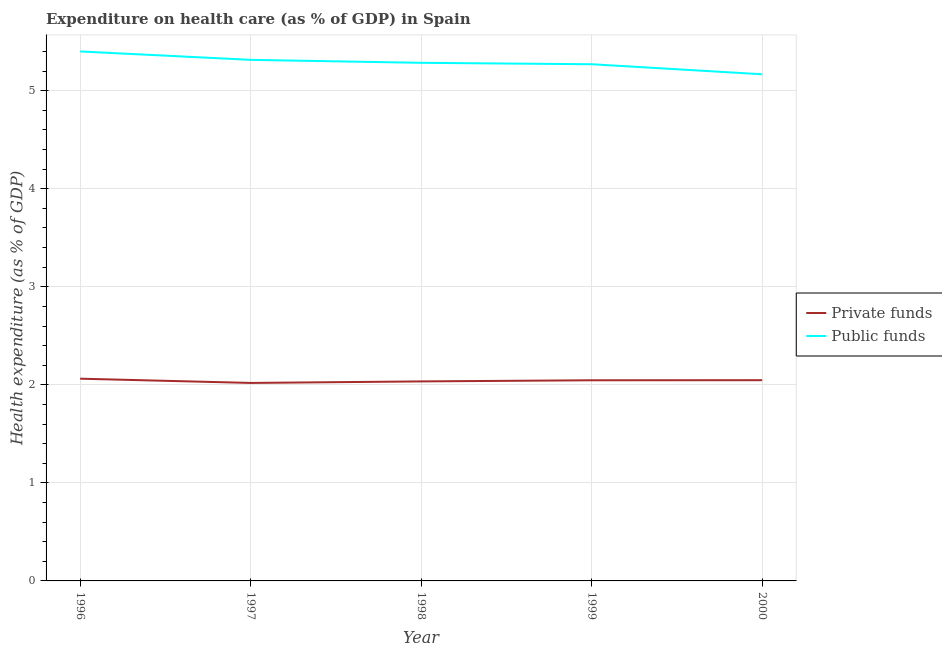Does the line corresponding to amount of public funds spent in healthcare intersect with the line corresponding to amount of private funds spent in healthcare?
Make the answer very short. No. Is the number of lines equal to the number of legend labels?
Provide a short and direct response. Yes. What is the amount of private funds spent in healthcare in 1996?
Provide a succinct answer. 2.06. Across all years, what is the maximum amount of private funds spent in healthcare?
Offer a terse response. 2.06. Across all years, what is the minimum amount of public funds spent in healthcare?
Keep it short and to the point. 5.17. What is the total amount of private funds spent in healthcare in the graph?
Offer a terse response. 10.21. What is the difference between the amount of public funds spent in healthcare in 1996 and that in 1998?
Make the answer very short. 0.12. What is the difference between the amount of private funds spent in healthcare in 1997 and the amount of public funds spent in healthcare in 2000?
Your answer should be compact. -3.15. What is the average amount of private funds spent in healthcare per year?
Ensure brevity in your answer.  2.04. In the year 2000, what is the difference between the amount of public funds spent in healthcare and amount of private funds spent in healthcare?
Offer a very short reply. 3.12. In how many years, is the amount of private funds spent in healthcare greater than 1.8 %?
Your answer should be compact. 5. What is the ratio of the amount of private funds spent in healthcare in 1997 to that in 1998?
Offer a very short reply. 0.99. Is the difference between the amount of private funds spent in healthcare in 1998 and 2000 greater than the difference between the amount of public funds spent in healthcare in 1998 and 2000?
Offer a terse response. No. What is the difference between the highest and the second highest amount of public funds spent in healthcare?
Offer a very short reply. 0.09. What is the difference between the highest and the lowest amount of public funds spent in healthcare?
Your response must be concise. 0.23. Does the amount of public funds spent in healthcare monotonically increase over the years?
Give a very brief answer. No. How many years are there in the graph?
Your response must be concise. 5. What is the difference between two consecutive major ticks on the Y-axis?
Keep it short and to the point. 1. Where does the legend appear in the graph?
Provide a succinct answer. Center right. How many legend labels are there?
Ensure brevity in your answer.  2. What is the title of the graph?
Give a very brief answer. Expenditure on health care (as % of GDP) in Spain. Does "Broad money growth" appear as one of the legend labels in the graph?
Provide a succinct answer. No. What is the label or title of the Y-axis?
Make the answer very short. Health expenditure (as % of GDP). What is the Health expenditure (as % of GDP) of Private funds in 1996?
Provide a succinct answer. 2.06. What is the Health expenditure (as % of GDP) in Public funds in 1996?
Offer a terse response. 5.4. What is the Health expenditure (as % of GDP) of Private funds in 1997?
Provide a succinct answer. 2.02. What is the Health expenditure (as % of GDP) in Public funds in 1997?
Your response must be concise. 5.31. What is the Health expenditure (as % of GDP) in Private funds in 1998?
Your answer should be compact. 2.03. What is the Health expenditure (as % of GDP) of Public funds in 1998?
Provide a short and direct response. 5.28. What is the Health expenditure (as % of GDP) in Private funds in 1999?
Make the answer very short. 2.05. What is the Health expenditure (as % of GDP) of Public funds in 1999?
Provide a short and direct response. 5.27. What is the Health expenditure (as % of GDP) of Private funds in 2000?
Provide a short and direct response. 2.05. What is the Health expenditure (as % of GDP) of Public funds in 2000?
Your response must be concise. 5.17. Across all years, what is the maximum Health expenditure (as % of GDP) in Private funds?
Ensure brevity in your answer.  2.06. Across all years, what is the maximum Health expenditure (as % of GDP) of Public funds?
Your answer should be compact. 5.4. Across all years, what is the minimum Health expenditure (as % of GDP) in Private funds?
Your answer should be very brief. 2.02. Across all years, what is the minimum Health expenditure (as % of GDP) in Public funds?
Keep it short and to the point. 5.17. What is the total Health expenditure (as % of GDP) in Private funds in the graph?
Make the answer very short. 10.21. What is the total Health expenditure (as % of GDP) of Public funds in the graph?
Your answer should be very brief. 26.44. What is the difference between the Health expenditure (as % of GDP) in Private funds in 1996 and that in 1997?
Make the answer very short. 0.04. What is the difference between the Health expenditure (as % of GDP) of Public funds in 1996 and that in 1997?
Ensure brevity in your answer.  0.09. What is the difference between the Health expenditure (as % of GDP) in Private funds in 1996 and that in 1998?
Keep it short and to the point. 0.03. What is the difference between the Health expenditure (as % of GDP) of Public funds in 1996 and that in 1998?
Your answer should be compact. 0.12. What is the difference between the Health expenditure (as % of GDP) in Private funds in 1996 and that in 1999?
Offer a terse response. 0.02. What is the difference between the Health expenditure (as % of GDP) of Public funds in 1996 and that in 1999?
Your response must be concise. 0.13. What is the difference between the Health expenditure (as % of GDP) of Private funds in 1996 and that in 2000?
Keep it short and to the point. 0.02. What is the difference between the Health expenditure (as % of GDP) of Public funds in 1996 and that in 2000?
Provide a succinct answer. 0.23. What is the difference between the Health expenditure (as % of GDP) in Private funds in 1997 and that in 1998?
Offer a terse response. -0.02. What is the difference between the Health expenditure (as % of GDP) of Public funds in 1997 and that in 1998?
Offer a very short reply. 0.03. What is the difference between the Health expenditure (as % of GDP) of Private funds in 1997 and that in 1999?
Ensure brevity in your answer.  -0.03. What is the difference between the Health expenditure (as % of GDP) in Public funds in 1997 and that in 1999?
Provide a succinct answer. 0.04. What is the difference between the Health expenditure (as % of GDP) of Private funds in 1997 and that in 2000?
Your response must be concise. -0.03. What is the difference between the Health expenditure (as % of GDP) of Public funds in 1997 and that in 2000?
Provide a short and direct response. 0.15. What is the difference between the Health expenditure (as % of GDP) in Private funds in 1998 and that in 1999?
Your response must be concise. -0.01. What is the difference between the Health expenditure (as % of GDP) of Public funds in 1998 and that in 1999?
Give a very brief answer. 0.01. What is the difference between the Health expenditure (as % of GDP) of Private funds in 1998 and that in 2000?
Your response must be concise. -0.01. What is the difference between the Health expenditure (as % of GDP) of Public funds in 1998 and that in 2000?
Offer a terse response. 0.12. What is the difference between the Health expenditure (as % of GDP) of Private funds in 1999 and that in 2000?
Provide a succinct answer. -0. What is the difference between the Health expenditure (as % of GDP) of Public funds in 1999 and that in 2000?
Provide a succinct answer. 0.1. What is the difference between the Health expenditure (as % of GDP) of Private funds in 1996 and the Health expenditure (as % of GDP) of Public funds in 1997?
Your response must be concise. -3.25. What is the difference between the Health expenditure (as % of GDP) of Private funds in 1996 and the Health expenditure (as % of GDP) of Public funds in 1998?
Your answer should be very brief. -3.22. What is the difference between the Health expenditure (as % of GDP) of Private funds in 1996 and the Health expenditure (as % of GDP) of Public funds in 1999?
Your response must be concise. -3.21. What is the difference between the Health expenditure (as % of GDP) in Private funds in 1996 and the Health expenditure (as % of GDP) in Public funds in 2000?
Make the answer very short. -3.1. What is the difference between the Health expenditure (as % of GDP) in Private funds in 1997 and the Health expenditure (as % of GDP) in Public funds in 1998?
Offer a terse response. -3.27. What is the difference between the Health expenditure (as % of GDP) of Private funds in 1997 and the Health expenditure (as % of GDP) of Public funds in 1999?
Offer a very short reply. -3.25. What is the difference between the Health expenditure (as % of GDP) in Private funds in 1997 and the Health expenditure (as % of GDP) in Public funds in 2000?
Ensure brevity in your answer.  -3.15. What is the difference between the Health expenditure (as % of GDP) of Private funds in 1998 and the Health expenditure (as % of GDP) of Public funds in 1999?
Provide a short and direct response. -3.23. What is the difference between the Health expenditure (as % of GDP) in Private funds in 1998 and the Health expenditure (as % of GDP) in Public funds in 2000?
Your answer should be very brief. -3.13. What is the difference between the Health expenditure (as % of GDP) in Private funds in 1999 and the Health expenditure (as % of GDP) in Public funds in 2000?
Provide a succinct answer. -3.12. What is the average Health expenditure (as % of GDP) in Private funds per year?
Offer a very short reply. 2.04. What is the average Health expenditure (as % of GDP) in Public funds per year?
Your response must be concise. 5.29. In the year 1996, what is the difference between the Health expenditure (as % of GDP) in Private funds and Health expenditure (as % of GDP) in Public funds?
Your answer should be compact. -3.34. In the year 1997, what is the difference between the Health expenditure (as % of GDP) in Private funds and Health expenditure (as % of GDP) in Public funds?
Keep it short and to the point. -3.3. In the year 1998, what is the difference between the Health expenditure (as % of GDP) of Private funds and Health expenditure (as % of GDP) of Public funds?
Make the answer very short. -3.25. In the year 1999, what is the difference between the Health expenditure (as % of GDP) of Private funds and Health expenditure (as % of GDP) of Public funds?
Provide a succinct answer. -3.22. In the year 2000, what is the difference between the Health expenditure (as % of GDP) of Private funds and Health expenditure (as % of GDP) of Public funds?
Give a very brief answer. -3.12. What is the ratio of the Health expenditure (as % of GDP) in Private funds in 1996 to that in 1997?
Your response must be concise. 1.02. What is the ratio of the Health expenditure (as % of GDP) in Public funds in 1996 to that in 1997?
Offer a very short reply. 1.02. What is the ratio of the Health expenditure (as % of GDP) in Private funds in 1996 to that in 1998?
Make the answer very short. 1.01. What is the ratio of the Health expenditure (as % of GDP) in Public funds in 1996 to that in 1998?
Provide a short and direct response. 1.02. What is the ratio of the Health expenditure (as % of GDP) of Private funds in 1996 to that in 1999?
Your answer should be very brief. 1.01. What is the ratio of the Health expenditure (as % of GDP) of Public funds in 1996 to that in 1999?
Give a very brief answer. 1.02. What is the ratio of the Health expenditure (as % of GDP) of Private funds in 1996 to that in 2000?
Provide a succinct answer. 1.01. What is the ratio of the Health expenditure (as % of GDP) of Public funds in 1996 to that in 2000?
Keep it short and to the point. 1.05. What is the ratio of the Health expenditure (as % of GDP) of Private funds in 1997 to that in 1999?
Give a very brief answer. 0.99. What is the ratio of the Health expenditure (as % of GDP) in Public funds in 1997 to that in 1999?
Make the answer very short. 1.01. What is the ratio of the Health expenditure (as % of GDP) of Private funds in 1997 to that in 2000?
Make the answer very short. 0.99. What is the ratio of the Health expenditure (as % of GDP) in Public funds in 1997 to that in 2000?
Ensure brevity in your answer.  1.03. What is the ratio of the Health expenditure (as % of GDP) of Private funds in 1998 to that in 1999?
Your answer should be very brief. 0.99. What is the ratio of the Health expenditure (as % of GDP) of Public funds in 1998 to that in 2000?
Your answer should be very brief. 1.02. What is the ratio of the Health expenditure (as % of GDP) of Public funds in 1999 to that in 2000?
Keep it short and to the point. 1.02. What is the difference between the highest and the second highest Health expenditure (as % of GDP) in Private funds?
Offer a very short reply. 0.02. What is the difference between the highest and the second highest Health expenditure (as % of GDP) of Public funds?
Provide a succinct answer. 0.09. What is the difference between the highest and the lowest Health expenditure (as % of GDP) in Private funds?
Offer a terse response. 0.04. What is the difference between the highest and the lowest Health expenditure (as % of GDP) in Public funds?
Ensure brevity in your answer.  0.23. 